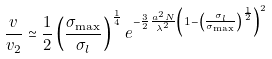<formula> <loc_0><loc_0><loc_500><loc_500>\frac { v } { v _ { 2 } } \simeq \frac { 1 } { 2 } \left ( \frac { \sigma _ { \max } } { \sigma _ { l } } \right ) ^ { \frac { 1 } { 4 } } e ^ { - \frac { 3 } { 2 } \frac { a ^ { 2 } N } { \lambda ^ { 2 } } \left ( 1 - \left ( \frac { \sigma _ { l } } { \sigma _ { \max } } \right ) ^ { \frac { 1 } { 2 } } \right ) ^ { 2 } }</formula> 